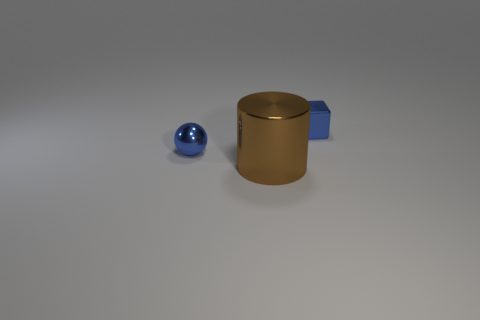How many other things are the same color as the tiny block?
Make the answer very short. 1. There is a small ball; is its color the same as the small shiny thing behind the metallic sphere?
Give a very brief answer. Yes. The shiny object that is in front of the metal block and behind the brown cylinder is what color?
Provide a short and direct response. Blue. Does the small metallic ball have the same color as the shiny block?
Keep it short and to the point. Yes. What is the material of the cube that is the same size as the metal ball?
Your response must be concise. Metal. What is the shape of the metallic object that is behind the shiny cylinder and on the right side of the ball?
Offer a terse response. Cube. The brown object that is made of the same material as the small blue ball is what size?
Offer a very short reply. Large. What number of balls are the same color as the metallic block?
Your answer should be very brief. 1. There is a shiny thing left of the brown thing; does it have the same color as the tiny cube?
Provide a short and direct response. Yes. What color is the large cylinder on the left side of the tiny blue cube?
Offer a very short reply. Brown. 